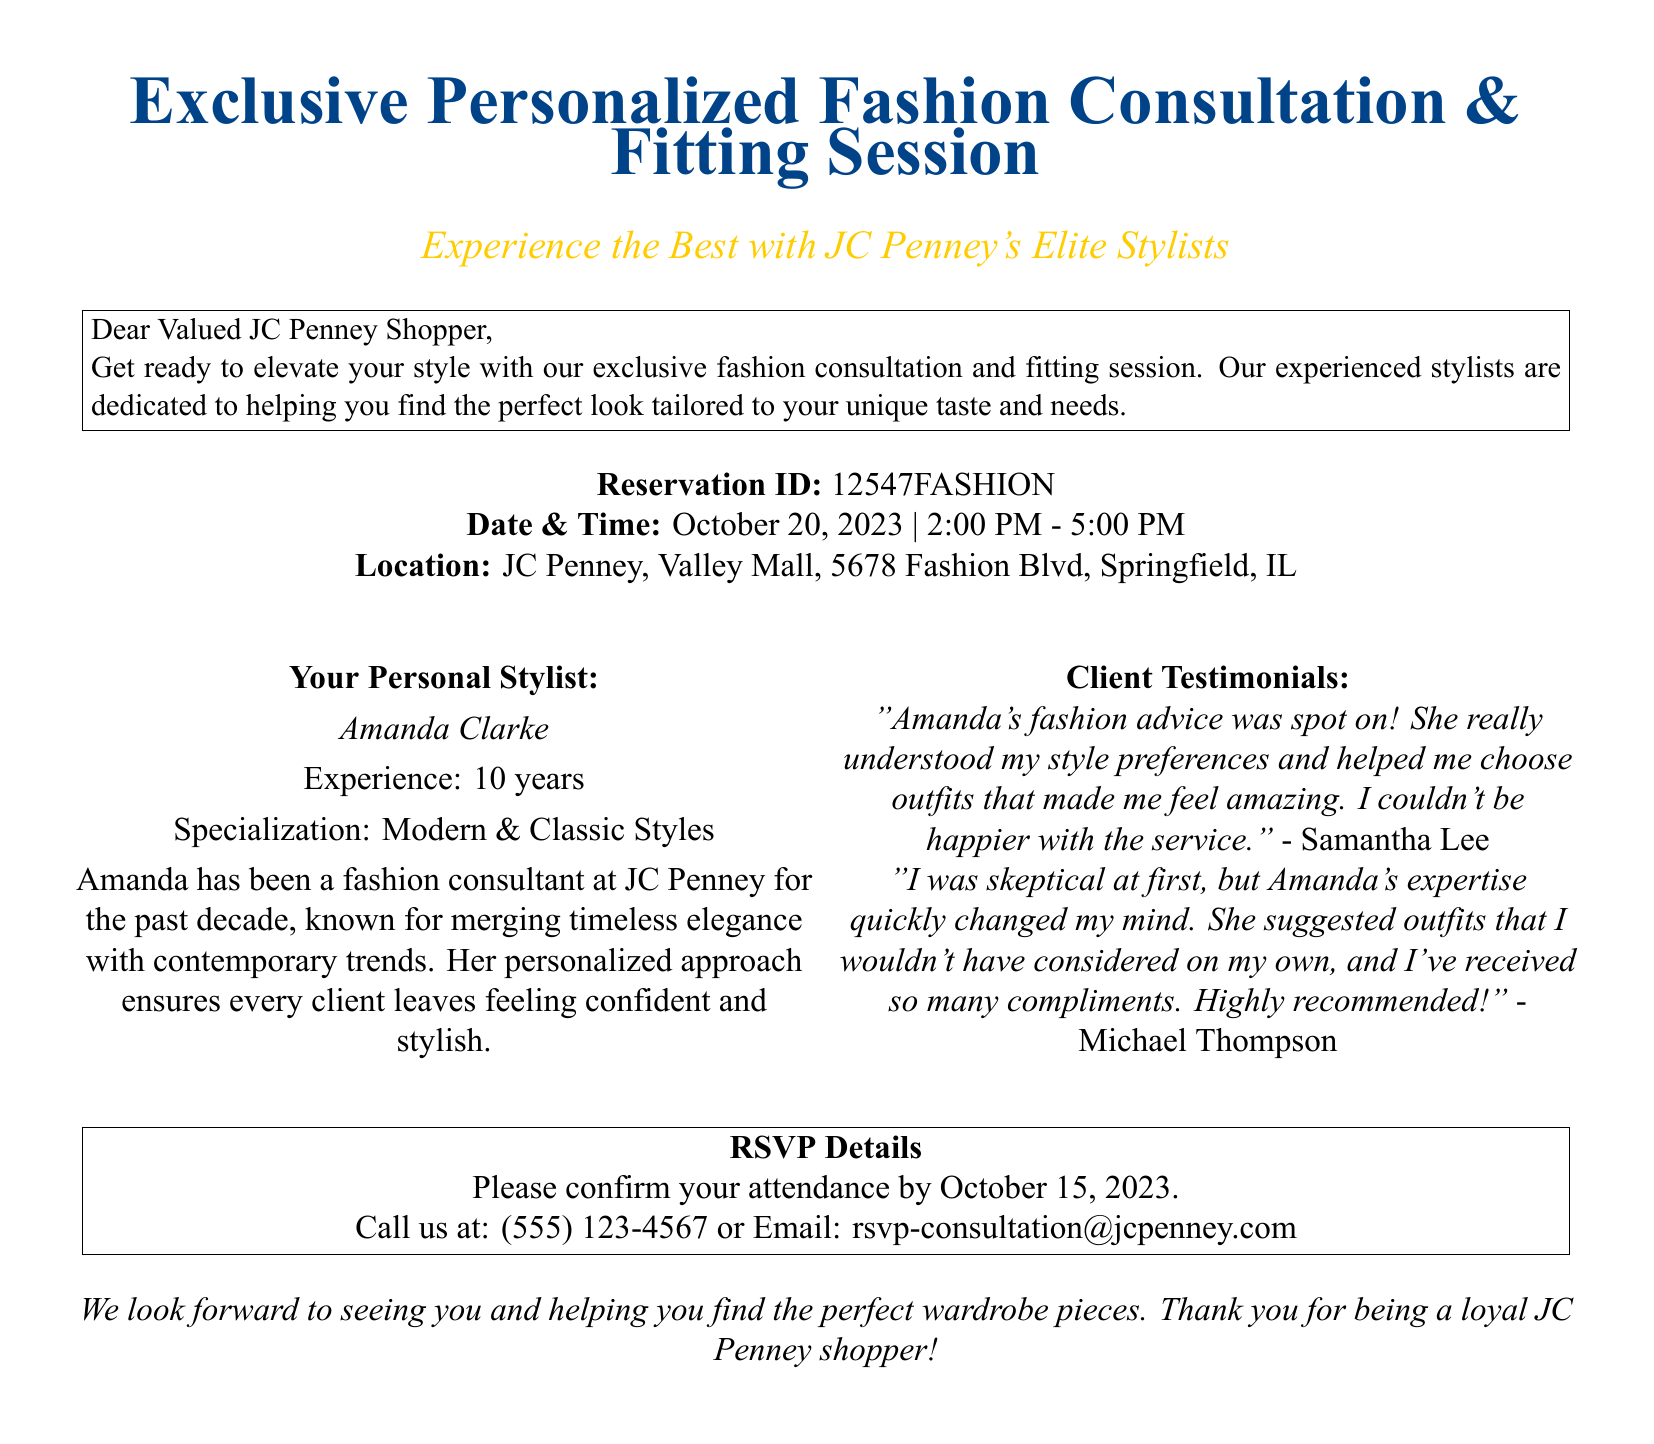What is the reservation ID? The reservation ID is a specific identifier provided in the document to confirm the reservation.
Answer: 12547FASHION Who is your personal stylist? The document specifies a stylist who will assist during the consultation session.
Answer: Amanda Clarke What is the date of the event? The date is mentioned clearly in the document for when the consultation will take place.
Answer: October 20, 2023 What time does the consultation start? The document lists the start time for the fashion consultation and fitting session event.
Answer: 2:00 PM How many years of experience does Amanda have? The duration of experience is included to highlight the stylist's background.
Answer: 10 years What is Amanda's specialization in fashion? The document outlines the specific styles that Amanda specializes in.
Answer: Modern & Classic Styles What is the deadline for RSVP? The RSVP deadline is provided to ensure the attendees confirm their participation on time.
Answer: October 15, 2023 How can attendees confirm their attendance? The document specifies the methods for contacting JC Penney to confirm attendance at the consultation.
Answer: Call or Email What is the location of the consultation? The location is detailed in the document for the attendees to know where to go.
Answer: JC Penney, Valley Mall, 5678 Fashion Blvd, Springfield, IL 